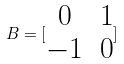Convert formula to latex. <formula><loc_0><loc_0><loc_500><loc_500>B = [ \begin{matrix} 0 & 1 \\ - 1 & 0 \end{matrix} ]</formula> 